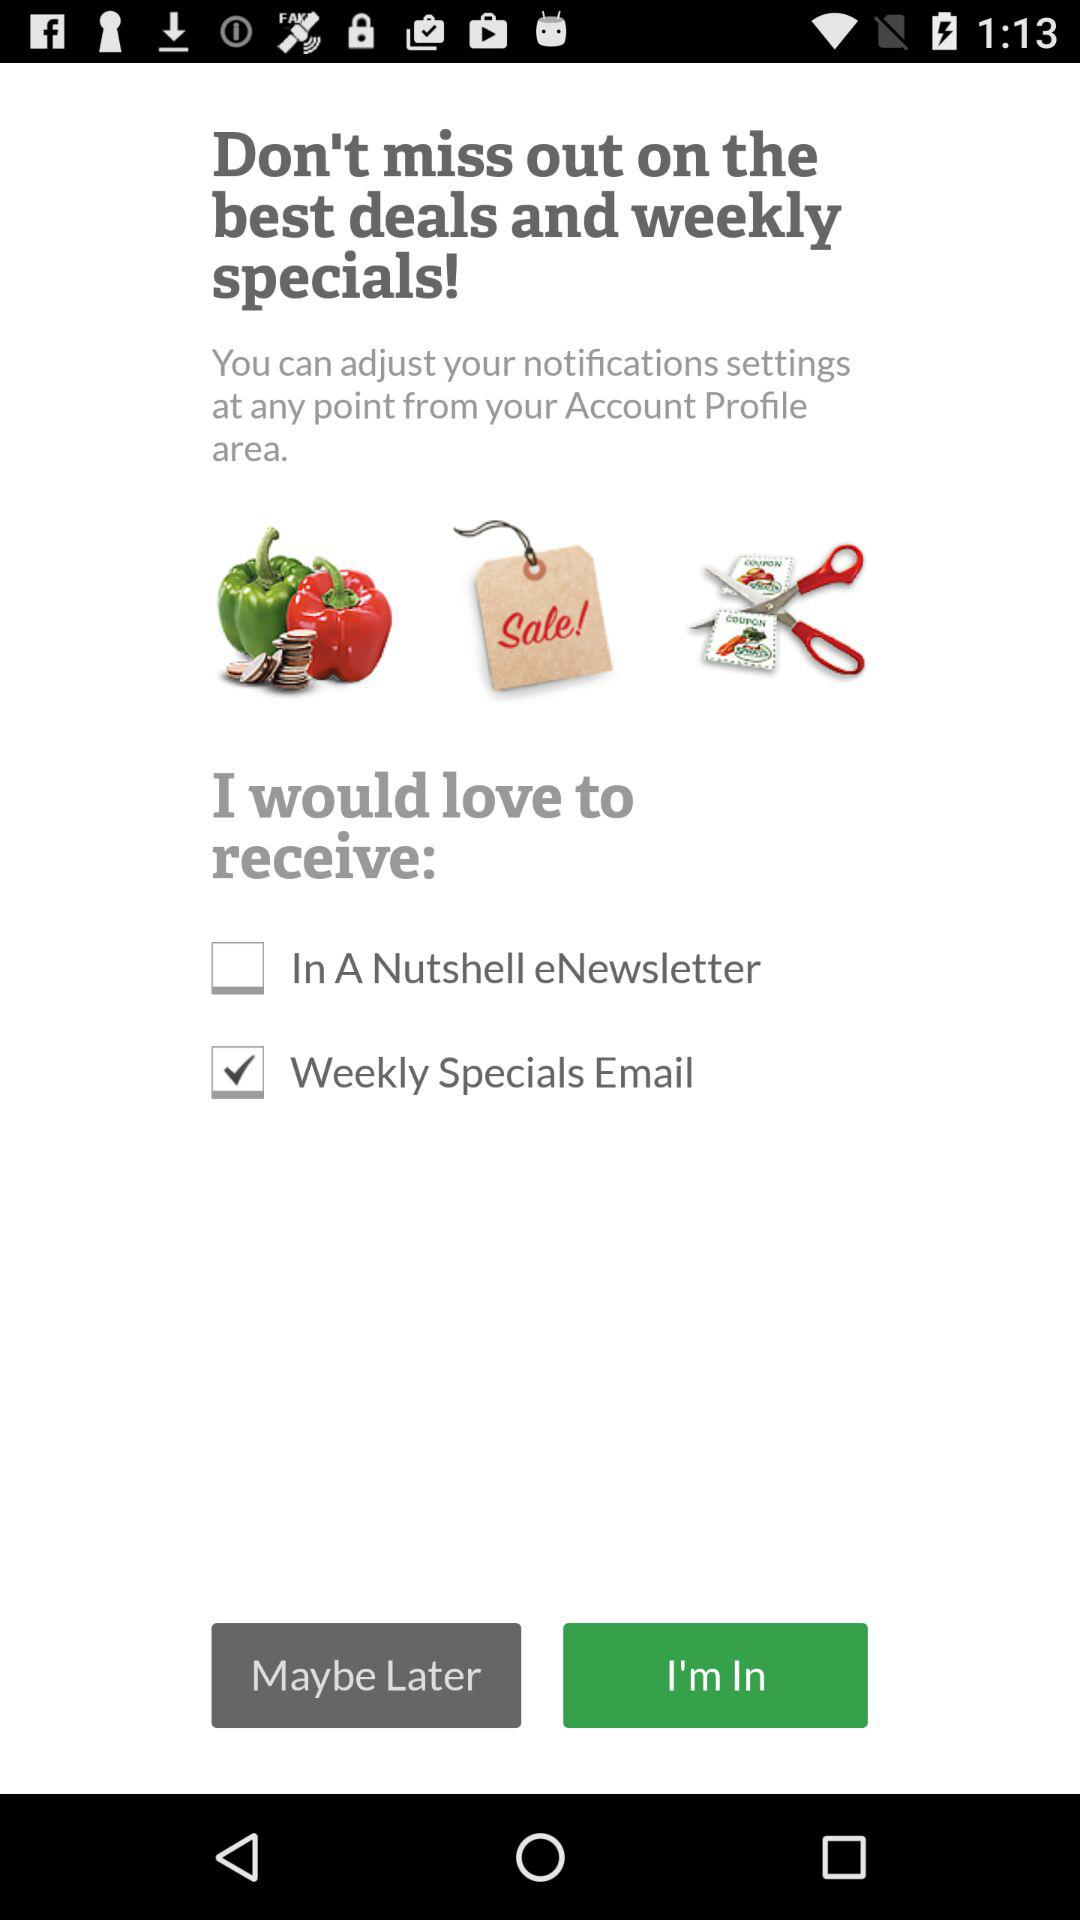How many items can I choose to receive?
Answer the question using a single word or phrase. 2 